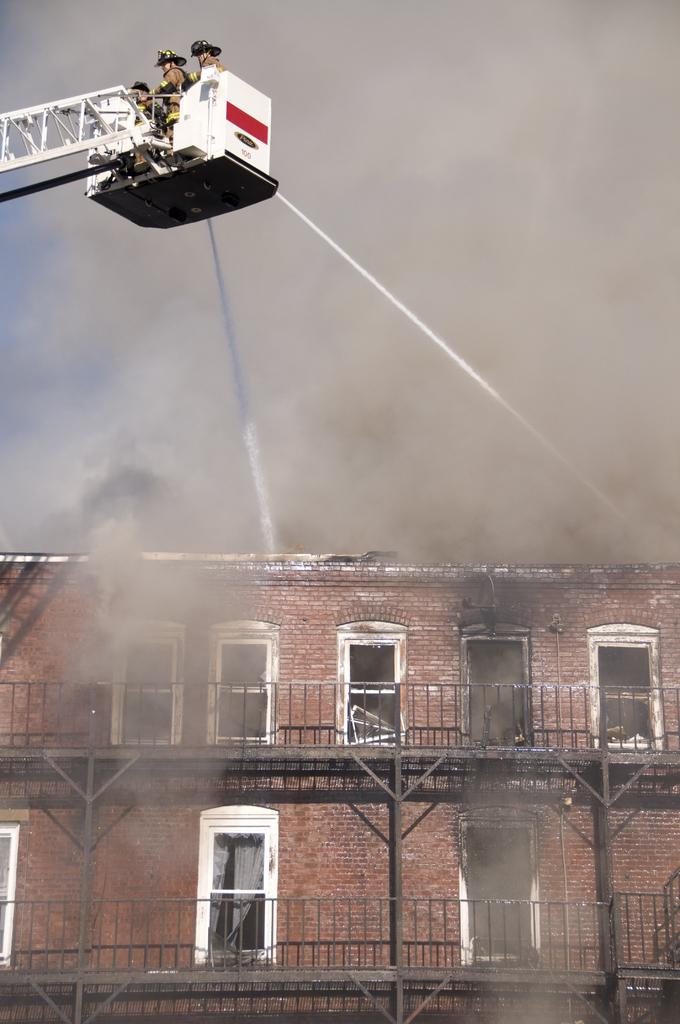What type of structure can be seen in the image? There is a building in the image. What is the unusual feature visible in the image? There is smoke visible in the image. What are the people doing in the image? There are people on a crane in the image. What natural element can be seen in the image? There is water visible in the image. What type of food can be seen on the tongue of the person in the image? There is no person or food visible in the image; it only shows a building, smoke, people on a crane, and water. 